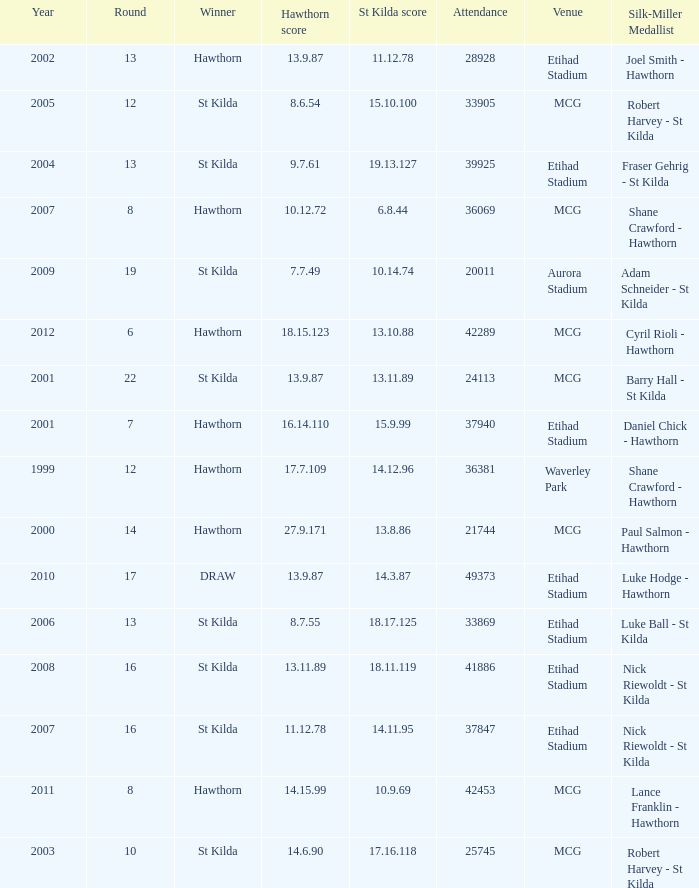What is the attendance when the st kilda score is 13.10.88? 42289.0. 